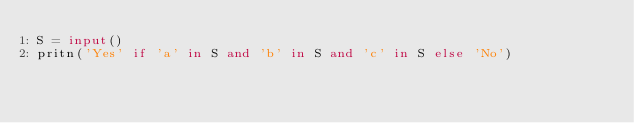Convert code to text. <code><loc_0><loc_0><loc_500><loc_500><_Python_>S = input()
pritn('Yes' if 'a' in S and 'b' in S and 'c' in S else 'No')</code> 